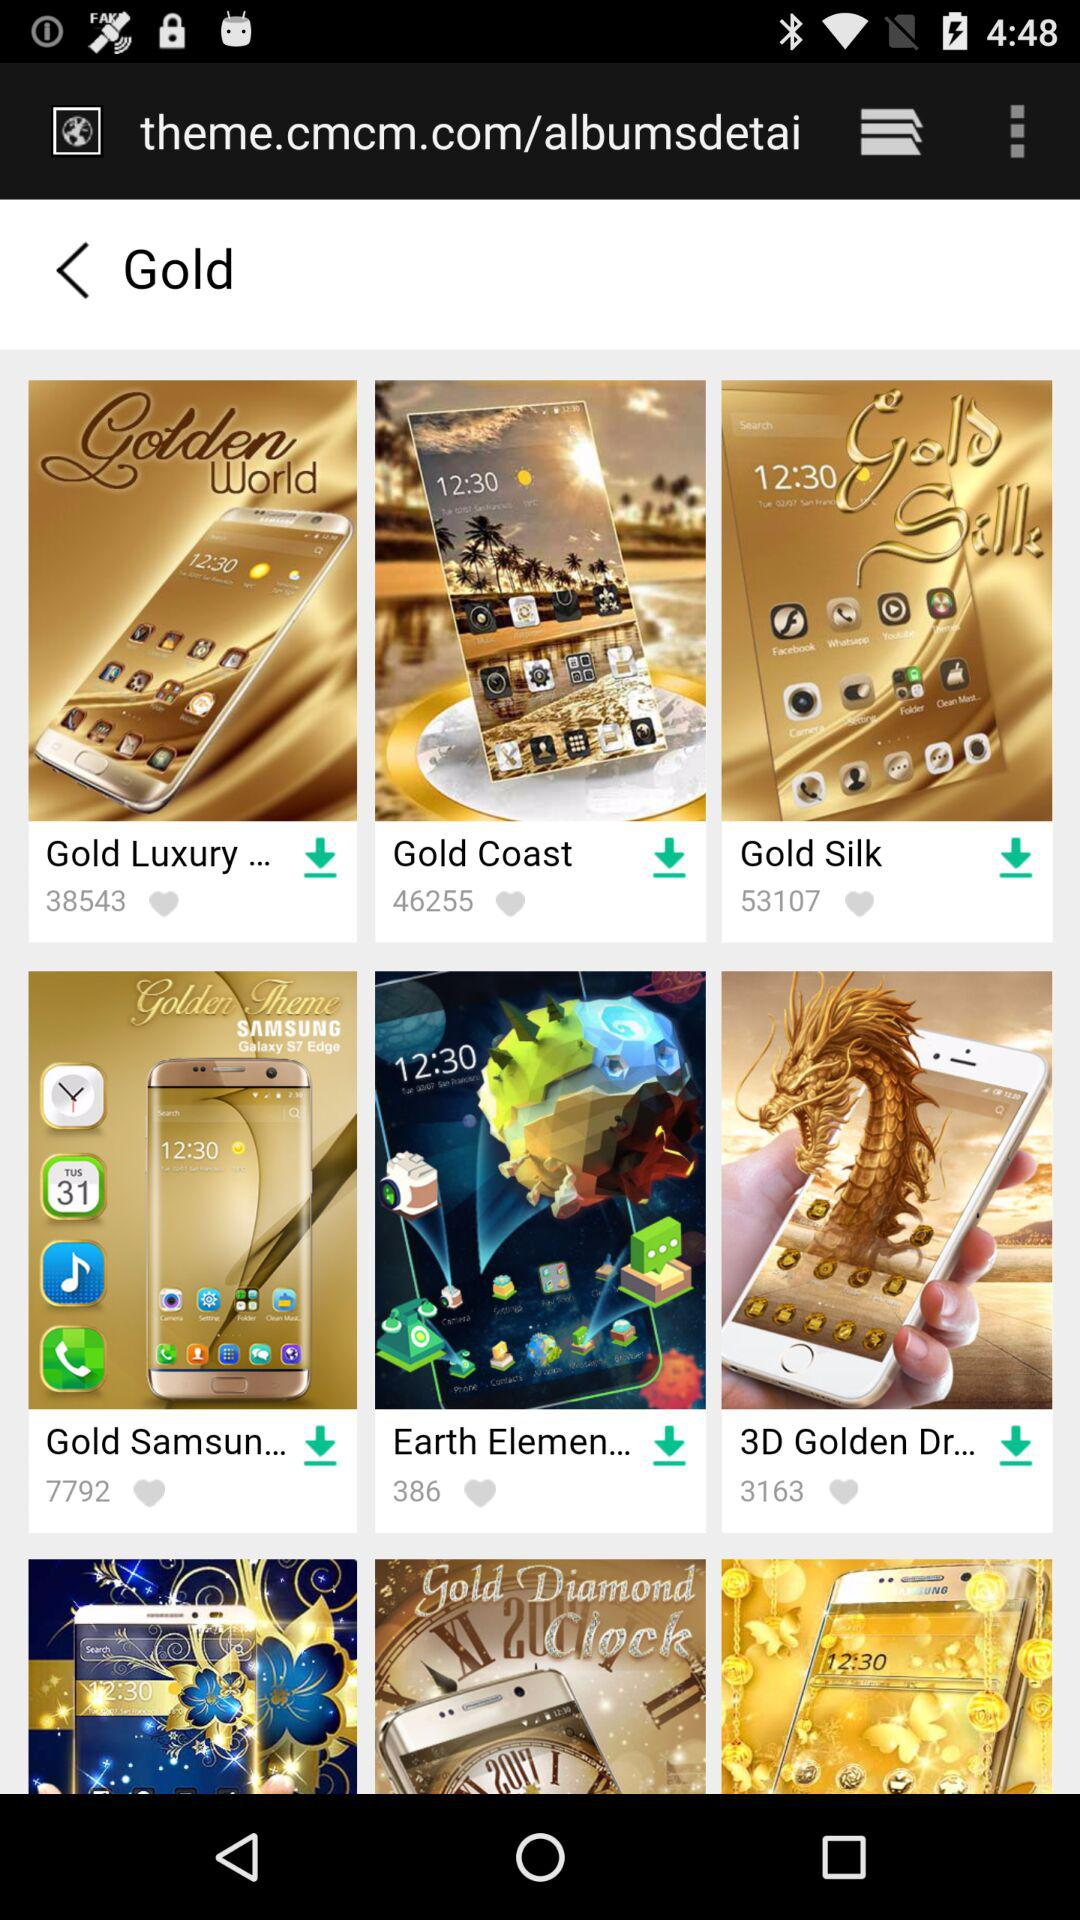How many likes on "Gold Luxury"? There are 38543 people who like "Gold Luxury". 